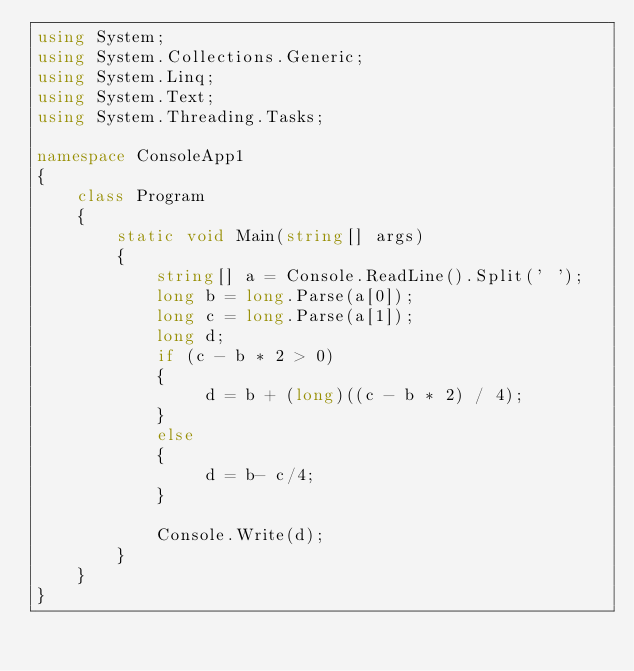<code> <loc_0><loc_0><loc_500><loc_500><_C#_>using System;
using System.Collections.Generic;
using System.Linq;
using System.Text;
using System.Threading.Tasks;

namespace ConsoleApp1
{
    class Program
    {
        static void Main(string[] args)
        {
            string[] a = Console.ReadLine().Split(' ');
            long b = long.Parse(a[0]);
            long c = long.Parse(a[1]);
            long d;
            if (c - b * 2 > 0)
            {
                 d = b + (long)((c - b * 2) / 4);
            }
            else
            {
                 d = b- c/4;
            }

            Console.Write(d);
        }
    }
}
</code> 